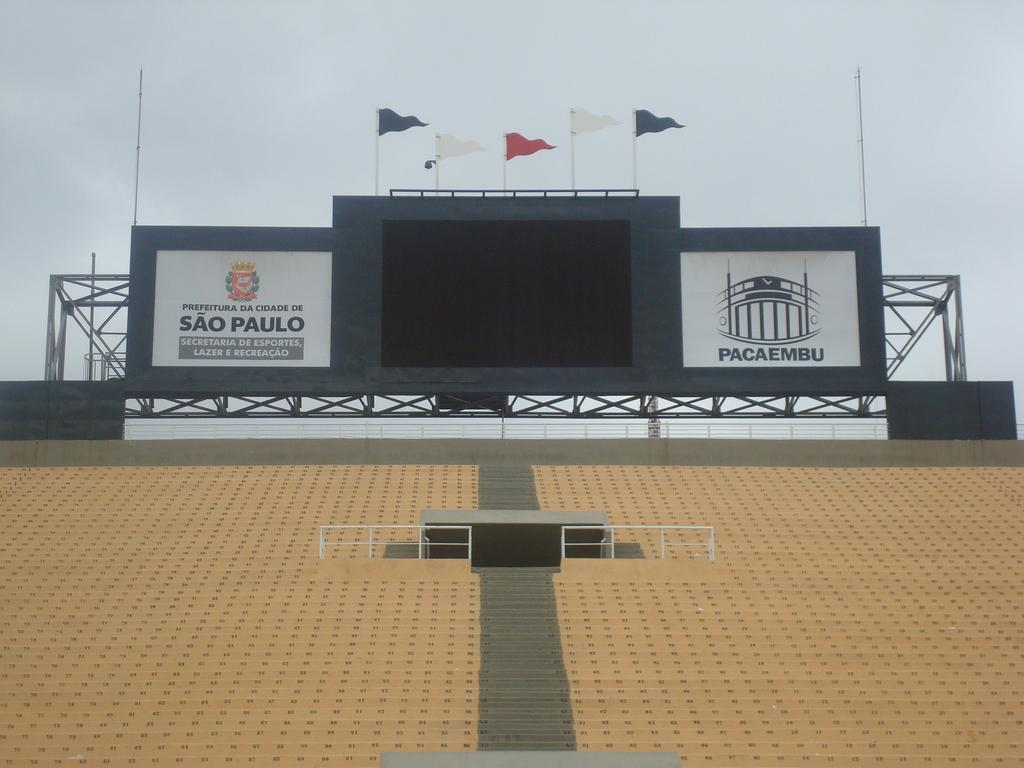<image>
Share a concise interpretation of the image provided. A large Sao Paulo sign hangs next to the digital scoreboard in an empty stadium. 